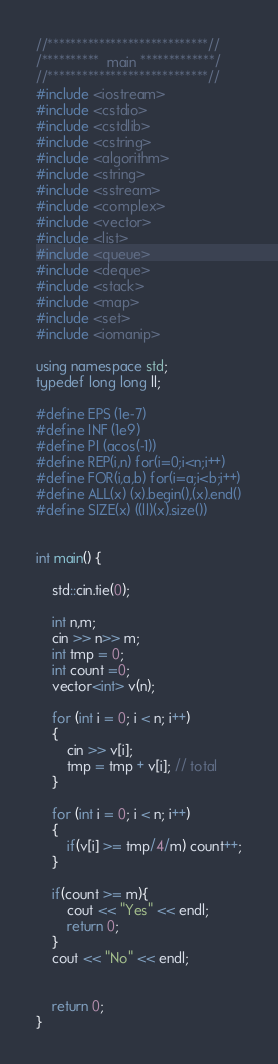<code> <loc_0><loc_0><loc_500><loc_500><_C++_>//****************************//
/**********  main *************/
//****************************//
#include <iostream>
#include <cstdio>
#include <cstdlib>
#include <cstring>
#include <algorithm>
#include <string>
#include <sstream>
#include <complex>
#include <vector>
#include <list>
#include <queue>
#include <deque>
#include <stack>
#include <map>
#include <set>
#include <iomanip>
 
using namespace std;
typedef long long ll;
 
#define EPS (1e-7)
#define INF (1e9)
#define PI (acos(-1))
#define REP(i,n) for(i=0;i<n;i++)
#define FOR(i,a,b) for(i=a;i<b;i++)
#define ALL(x) (x).begin(),(x).end()
#define SIZE(x) ((ll)(x).size())


int main() {

	std::cin.tie(0);

    int n,m;
    cin >> n>> m;
    int tmp = 0;
    int count =0;
    vector<int> v(n);

    for (int i = 0; i < n; i++)
    {
        cin >> v[i];
        tmp = tmp + v[i]; // total 
    }

    for (int i = 0; i < n; i++)
    {
        if(v[i] >= tmp/4/m) count++;
    }    

    if(count >= m){
        cout << "Yes" << endl;
        return 0;
    }
    cout << "No" << endl;


    return 0;
}</code> 